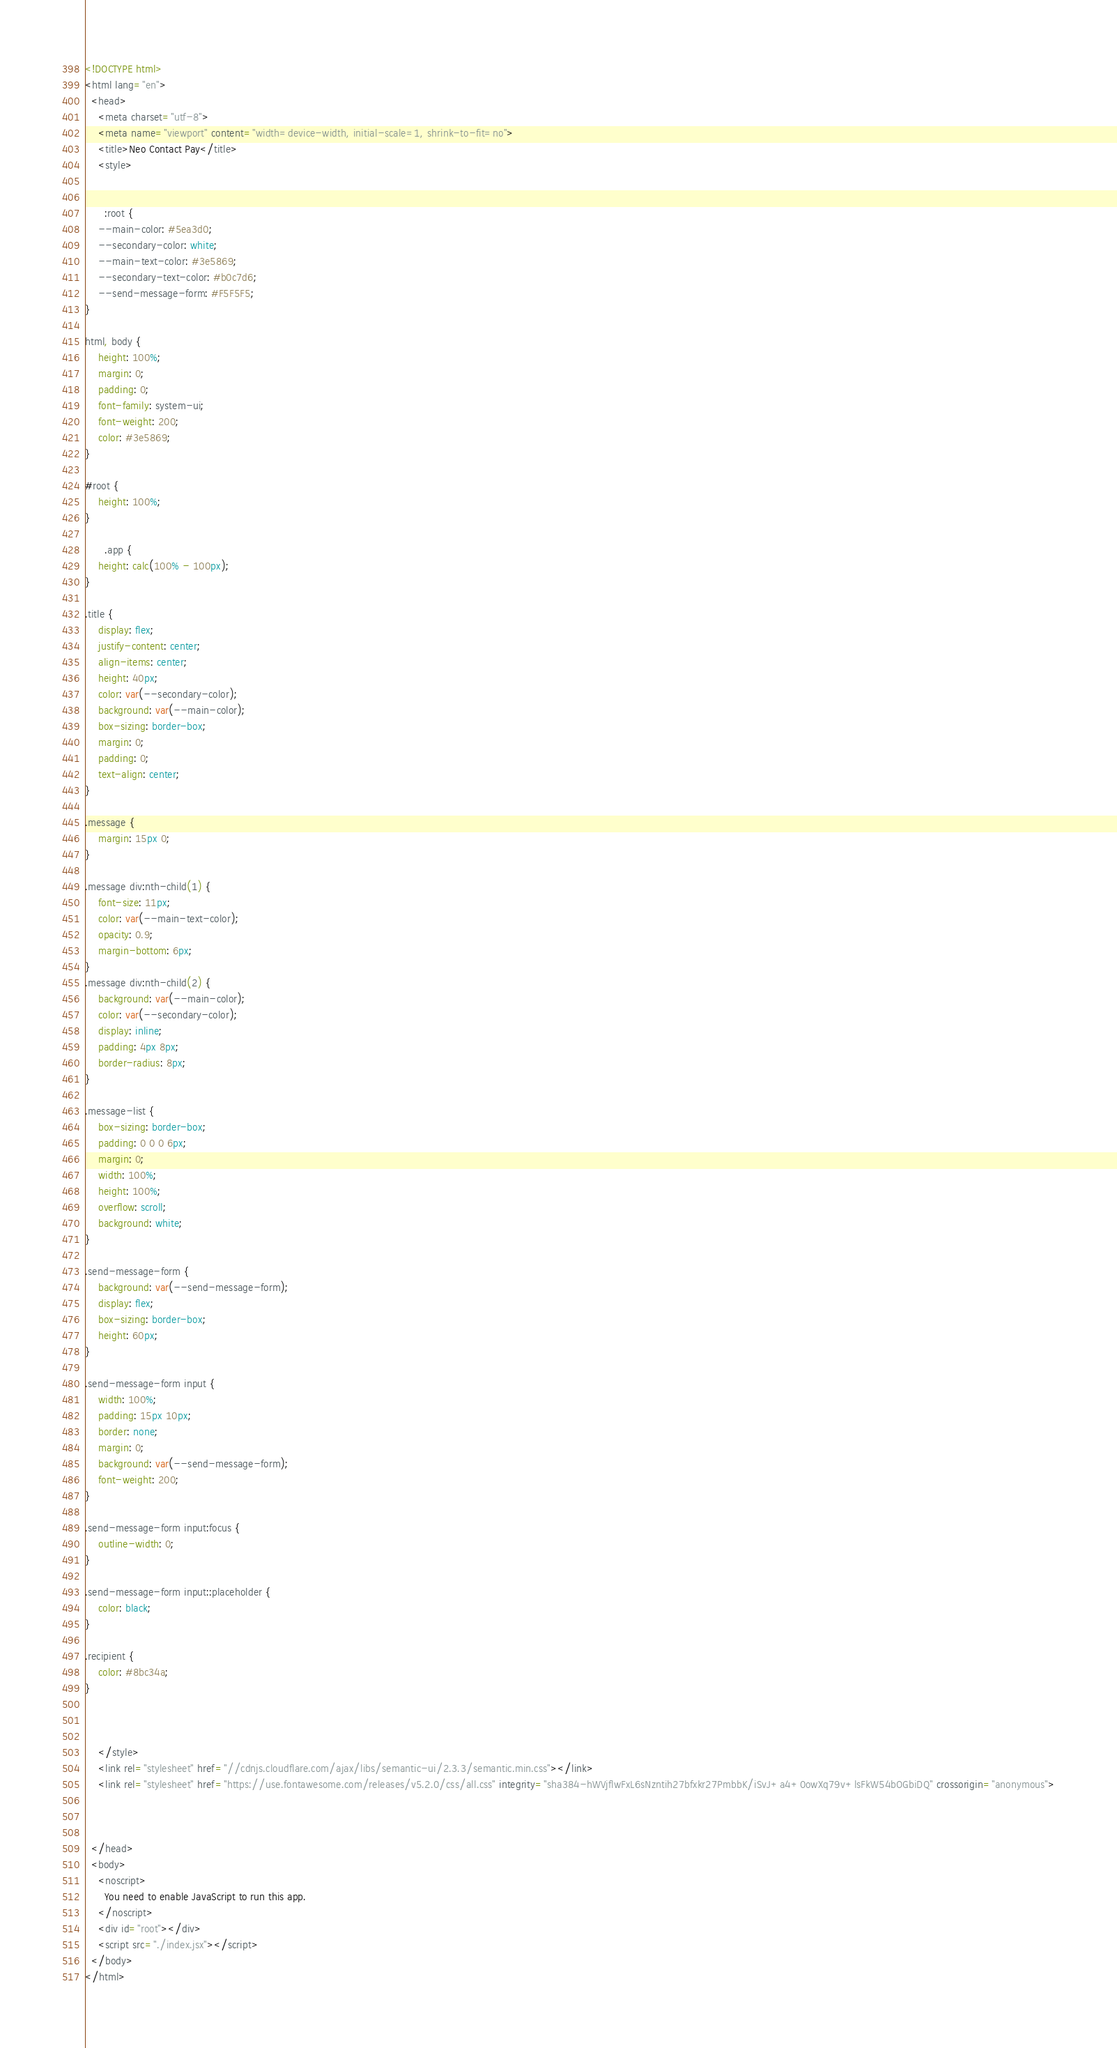<code> <loc_0><loc_0><loc_500><loc_500><_HTML_><!DOCTYPE html>
<html lang="en">
  <head>
    <meta charset="utf-8">
    <meta name="viewport" content="width=device-width, initial-scale=1, shrink-to-fit=no">
    <title>Neo Contact Pay</title>
    <style>


      :root {
    --main-color: #5ea3d0;
    --secondary-color: white;
    --main-text-color: #3e5869;
    --secondary-text-color: #b0c7d6;
    --send-message-form: #F5F5F5;
}

html, body {
    height: 100%;
    margin: 0;
    padding: 0;
    font-family: system-ui;
    font-weight: 200;
    color: #3e5869; 
}

#root {
    height: 100%;
}

      .app {
    height: calc(100% - 100px); 
}

.title {
    display: flex;
    justify-content: center;
    align-items: center;
    height: 40px;
    color: var(--secondary-color);
    background: var(--main-color);
    box-sizing: border-box;
    margin: 0;
    padding: 0;
    text-align: center;
}

.message {
    margin: 15px 0;
}

.message div:nth-child(1) {
    font-size: 11px;
    color: var(--main-text-color);
    opacity: 0.9;
    margin-bottom: 6px;
}
.message div:nth-child(2) {
    background: var(--main-color);
    color: var(--secondary-color);
    display: inline;
    padding: 4px 8px;
    border-radius: 8px;
}

.message-list {
    box-sizing: border-box;
    padding: 0 0 0 6px;
    margin: 0;
    width: 100%;
    height: 100%;
    overflow: scroll;
    background: white;
}

.send-message-form {
    background: var(--send-message-form);
    display: flex;
    box-sizing: border-box;
    height: 60px;
}

.send-message-form input {
    width: 100%;
    padding: 15px 10px;
    border: none;
    margin: 0;
    background: var(--send-message-form);
    font-weight: 200;
}

.send-message-form input:focus {
    outline-width: 0;
}

.send-message-form input::placeholder {
    color: black;
}

.recipient {
    color: #8bc34a;
}
    
    
    
    </style>
    <link rel="stylesheet" href="//cdnjs.cloudflare.com/ajax/libs/semantic-ui/2.3.3/semantic.min.css"></link>
    <link rel="stylesheet" href="https://use.fontawesome.com/releases/v5.2.0/css/all.css" integrity="sha384-hWVjflwFxL6sNzntih27bfxkr27PmbbK/iSvJ+a4+0owXq79v+lsFkW54bOGbiDQ" crossorigin="anonymous">



  </head>
  <body>
    <noscript>
      You need to enable JavaScript to run this app.
    </noscript>
    <div id="root"></div>
    <script src="./index.jsx"></script>
  </body>
</html>
</code> 